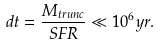Convert formula to latex. <formula><loc_0><loc_0><loc_500><loc_500>d t = \frac { M _ { t r u n c } } { S F R } \ll 1 0 ^ { 6 } y r .</formula> 